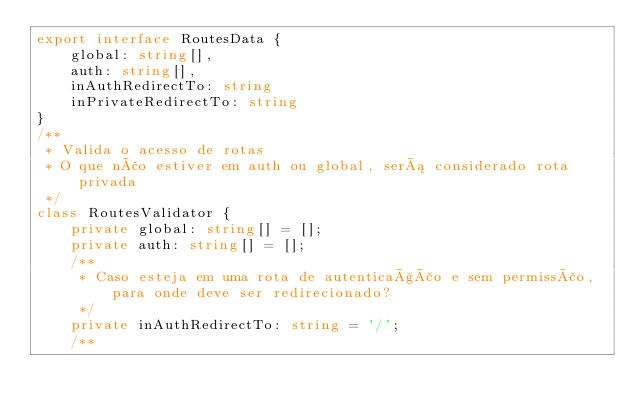Convert code to text. <code><loc_0><loc_0><loc_500><loc_500><_TypeScript_>export interface RoutesData {
    global: string[],
    auth: string[],
    inAuthRedirectTo: string
    inPrivateRedirectTo: string
}
/**
 * Valida o acesso de rotas
 * O que não estiver em auth ou global, será considerado rota privada
 */
class RoutesValidator {
    private global: string[] = [];
    private auth: string[] = [];
    /**
     * Caso esteja em uma rota de autenticação e sem permissão, para onde deve ser redirecionado?
     */
    private inAuthRedirectTo: string = '/';
    /**</code> 